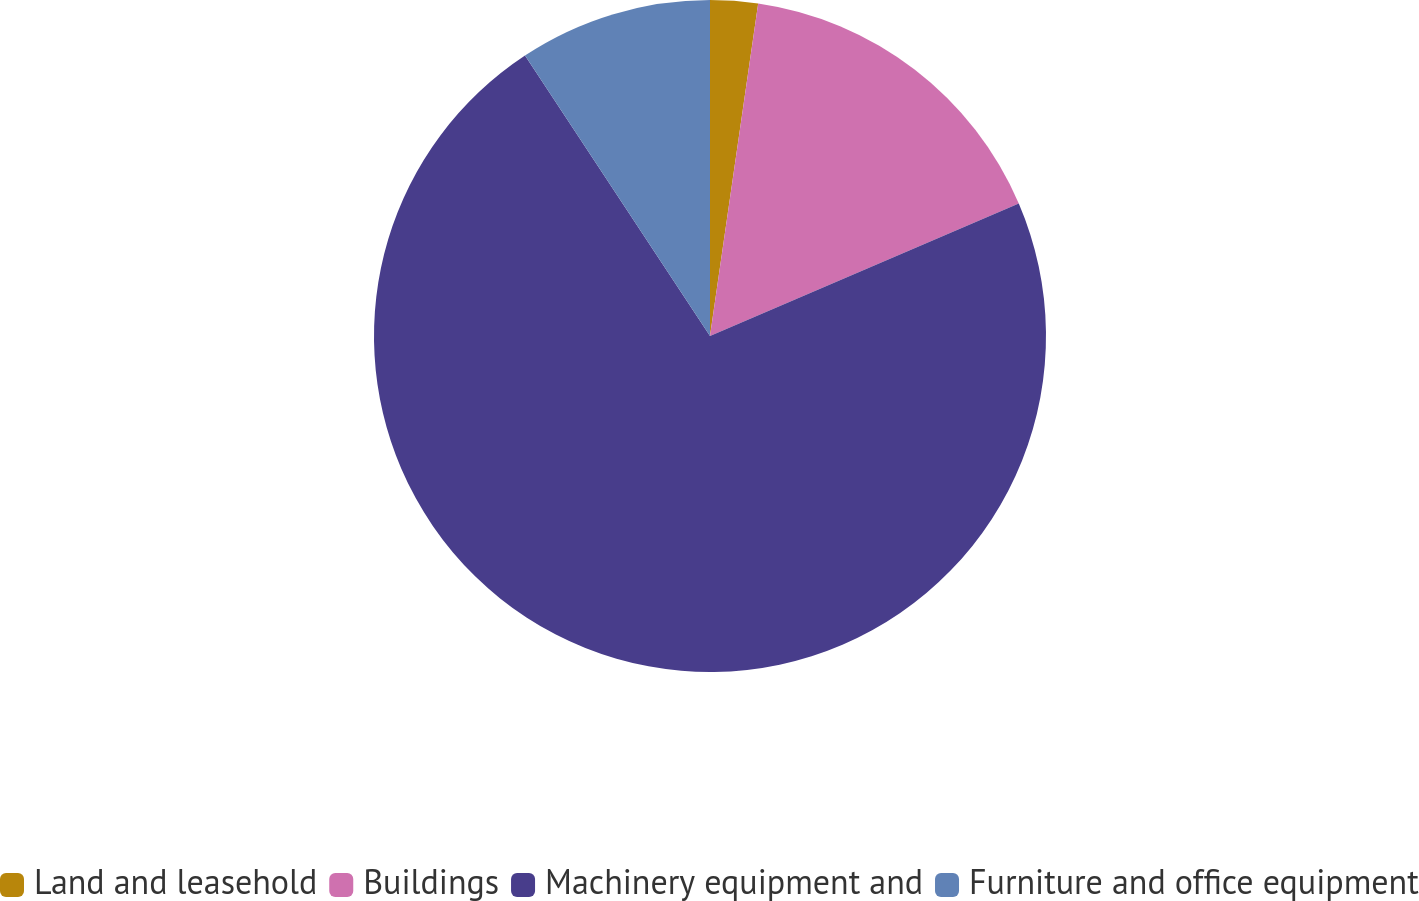Convert chart. <chart><loc_0><loc_0><loc_500><loc_500><pie_chart><fcel>Land and leasehold<fcel>Buildings<fcel>Machinery equipment and<fcel>Furniture and office equipment<nl><fcel>2.29%<fcel>16.26%<fcel>72.17%<fcel>9.28%<nl></chart> 